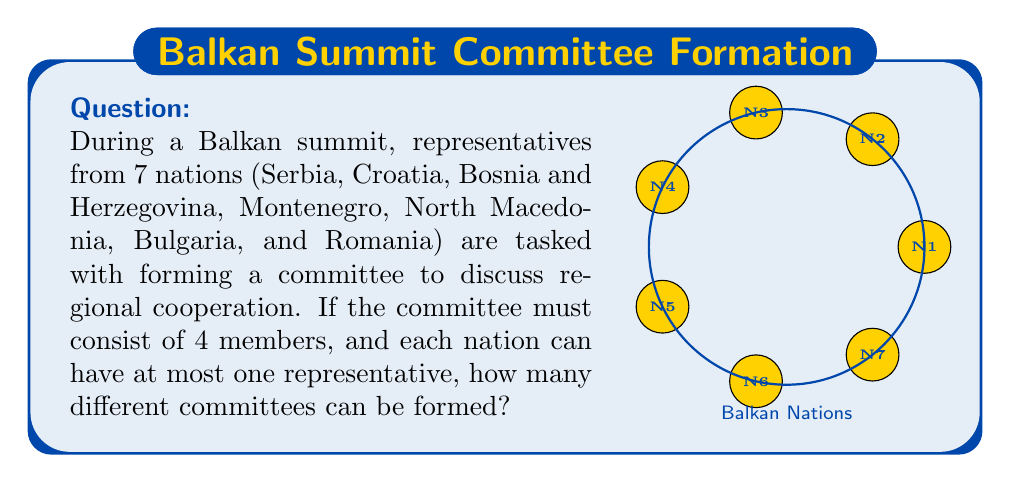Could you help me with this problem? This problem can be solved using the combination formula. We need to select 4 representatives out of 7 nations, where the order doesn't matter (as it's a committee, not an ordered list).

The formula for combinations is:

$$ C(n,r) = \frac{n!}{r!(n-r)!} $$

Where:
- $n$ is the total number of items to choose from (in this case, 7 nations)
- $r$ is the number of items being chosen (in this case, 4 committee members)

Let's plug in our values:

$$ C(7,4) = \frac{7!}{4!(7-4)!} = \frac{7!}{4!3!} $$

Now, let's calculate this step-by-step:

1) $7! = 7 \times 6 \times 5 \times 4 \times 3 \times 2 \times 1 = 5040$
2) $4! = 4 \times 3 \times 2 \times 1 = 24$
3) $3! = 3 \times 2 \times 1 = 6$

Substituting these values:

$$ C(7,4) = \frac{5040}{24 \times 6} = \frac{5040}{144} = 35 $$

Therefore, there are 35 different ways to form a committee of 4 members from 7 nations.
Answer: 35 